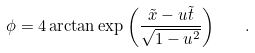<formula> <loc_0><loc_0><loc_500><loc_500>\phi = 4 \arctan \exp \left ( \frac { \tilde { x } - u \tilde { t } } { \sqrt { 1 - u ^ { 2 } } } \right ) \quad .</formula> 